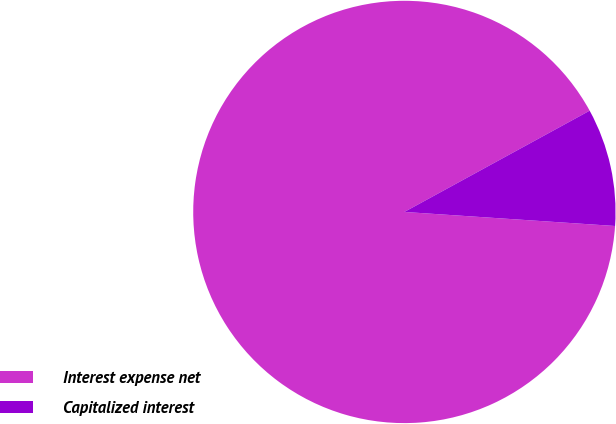<chart> <loc_0><loc_0><loc_500><loc_500><pie_chart><fcel>Interest expense net<fcel>Capitalized interest<nl><fcel>90.98%<fcel>9.02%<nl></chart> 